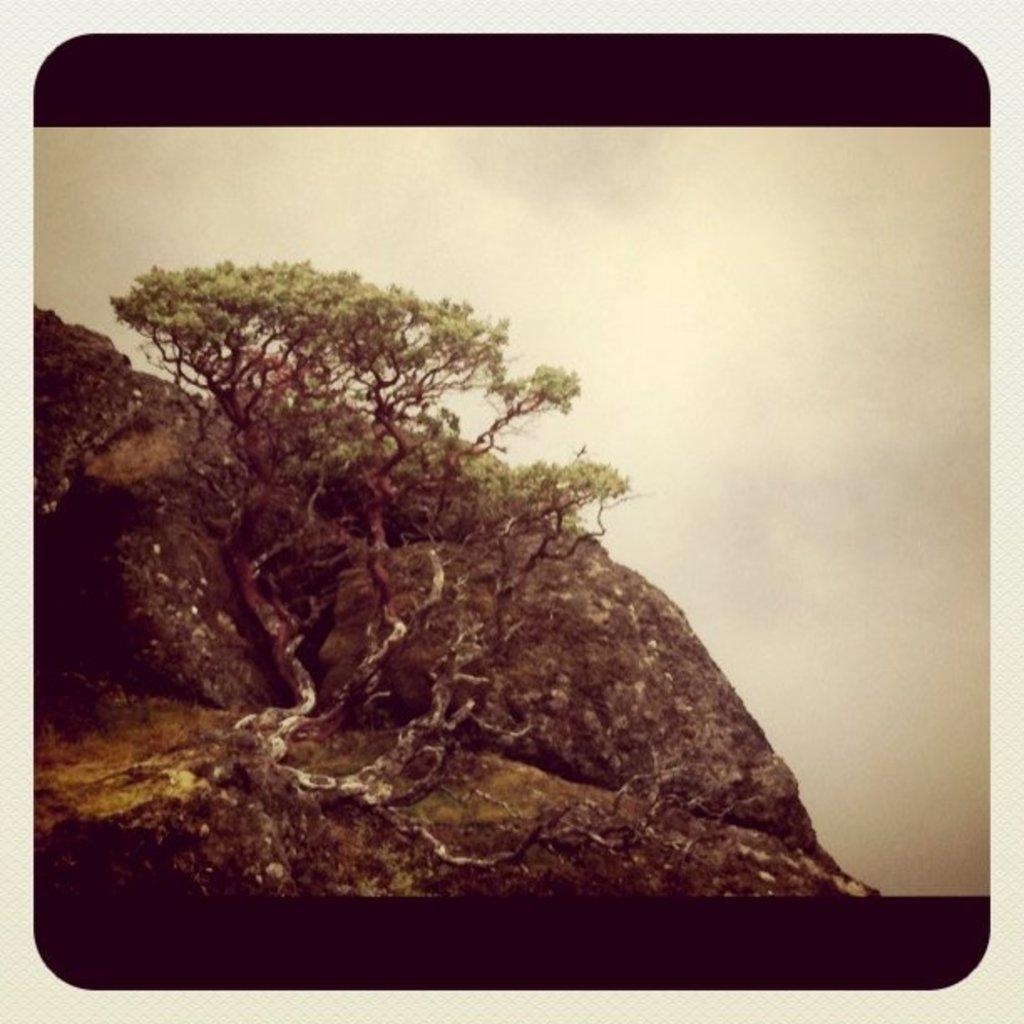What is the main feature in the image? There is a huge rock in the image. Is there any vegetation on the rock? Yes, there is a tree on the rock. What type of support can be seen under the tree on the rock? There is no visible support under the tree on the rock in the image. What is the source of the spark that can be seen near the tree? There is no spark visible near the tree in the image. 